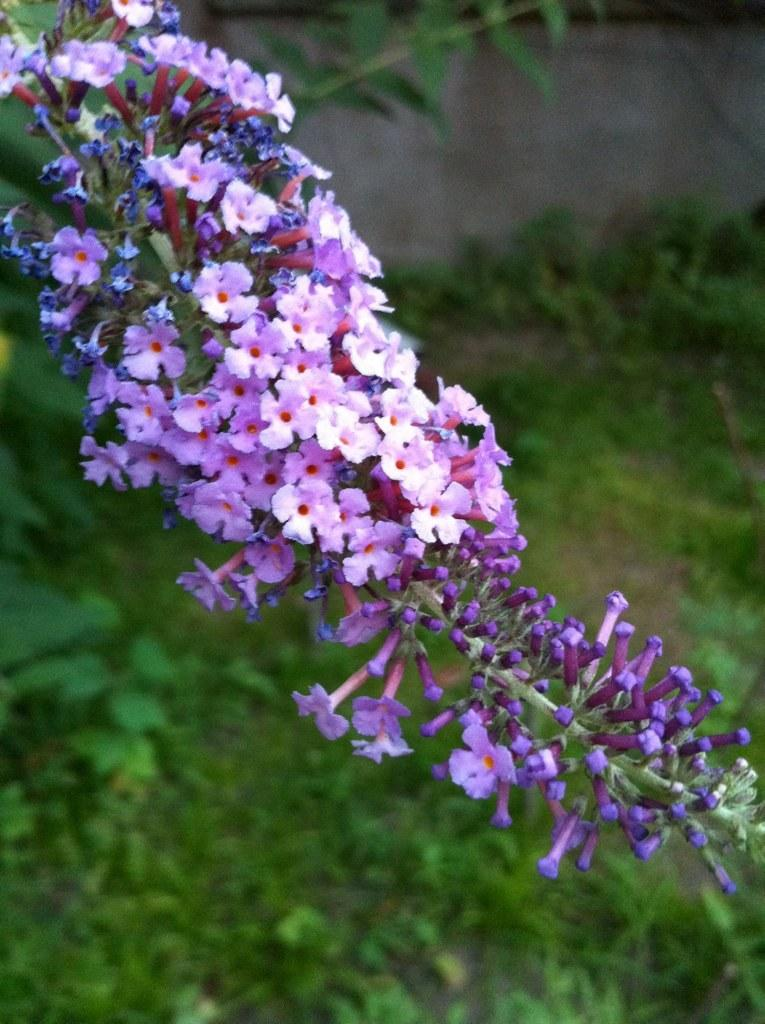What can be seen in the foreground of the image? There are flowers in the foreground of the image. What is visible in the background of the image? There are plants and a wall in the background of the image. What type of jelly can be seen on the wall in the image? There is no jelly present on the wall in the image. How far does the range of the flowers extend in the image? The range of the flowers cannot be determined from the image, as it only shows their presence in the foreground. 